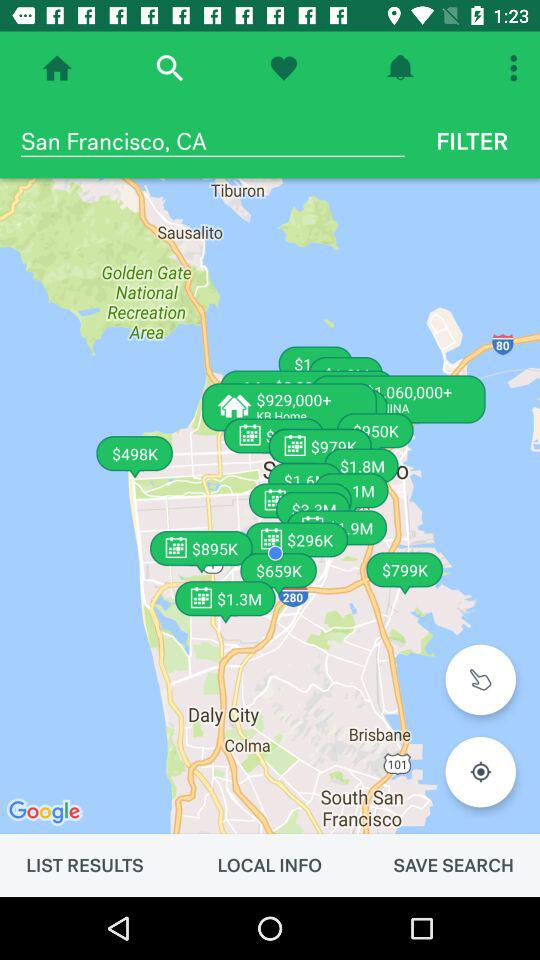What is the current location? The current location is San Francisco, CA. 